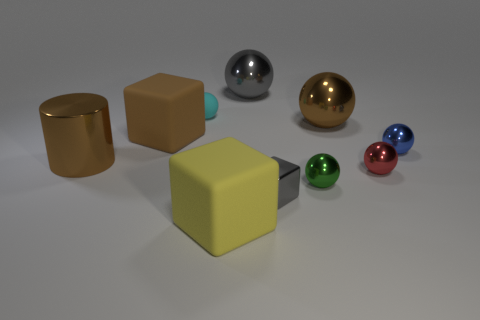Subtract all blue spheres. How many spheres are left? 5 Subtract all gray balls. How many balls are left? 5 Subtract all spheres. How many objects are left? 4 Subtract all blue balls. Subtract all brown cylinders. How many balls are left? 5 Subtract all big metal cylinders. Subtract all tiny blue shiny balls. How many objects are left? 8 Add 1 tiny cyan balls. How many tiny cyan balls are left? 2 Add 6 purple cylinders. How many purple cylinders exist? 6 Subtract 0 green cylinders. How many objects are left? 10 